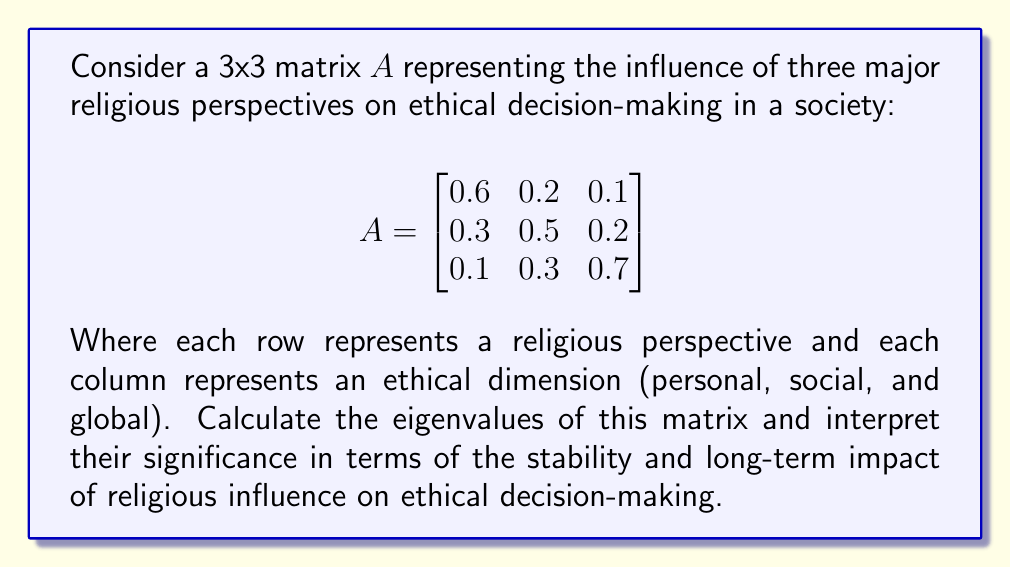Show me your answer to this math problem. To find the eigenvalues of matrix $A$, we need to solve the characteristic equation:

1) First, we calculate $det(A - \lambda I)$:

   $$det\begin{pmatrix}
   0.6-\lambda & 0.2 & 0.1 \\
   0.3 & 0.5-\lambda & 0.2 \\
   0.1 & 0.3 & 0.7-\lambda
   \end{pmatrix} = 0$$

2) Expanding the determinant:
   
   $(0.6-\lambda)[(0.5-\lambda)(0.7-\lambda)-0.06] - 0.2[0.3(0.7-\lambda)-0.02] + 0.1[0.3(0.5-\lambda)-0.06] = 0$

3) Simplifying:
   
   $-\lambda^3 + 1.8\lambda^2 - 0.89\lambda + 0.122 = 0$

4) This cubic equation can be solved using numerical methods. The eigenvalues are approximately:

   $\lambda_1 \approx 1.0000$
   $\lambda_2 \approx 0.4657$
   $\lambda_3 \approx 0.3343$

5) Interpretation:
   - The largest eigenvalue (1.0000) suggests a stable, dominant influence of religion on ethics.
   - The other two eigenvalues (0.4657 and 0.3343) indicate secondary and tertiary influences that are less dominant but still significant.
   - All eigenvalues are positive and real, suggesting a stable system without oscillatory behavior.
   - The sum of eigenvalues (1.8) equals the trace of the matrix, confirming our calculations.

This analysis suggests that religious influence on ethical decision-making in this model is stable and persistent, with one dominant mode of influence and two lesser, but still important, modes.
Answer: Eigenvalues: $\lambda_1 \approx 1.0000$, $\lambda_2 \approx 0.4657$, $\lambda_3 \approx 0.3343$ 